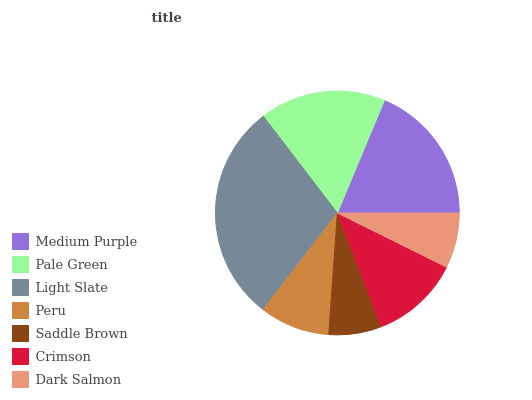Is Saddle Brown the minimum?
Answer yes or no. Yes. Is Light Slate the maximum?
Answer yes or no. Yes. Is Pale Green the minimum?
Answer yes or no. No. Is Pale Green the maximum?
Answer yes or no. No. Is Medium Purple greater than Pale Green?
Answer yes or no. Yes. Is Pale Green less than Medium Purple?
Answer yes or no. Yes. Is Pale Green greater than Medium Purple?
Answer yes or no. No. Is Medium Purple less than Pale Green?
Answer yes or no. No. Is Crimson the high median?
Answer yes or no. Yes. Is Crimson the low median?
Answer yes or no. Yes. Is Medium Purple the high median?
Answer yes or no. No. Is Pale Green the low median?
Answer yes or no. No. 